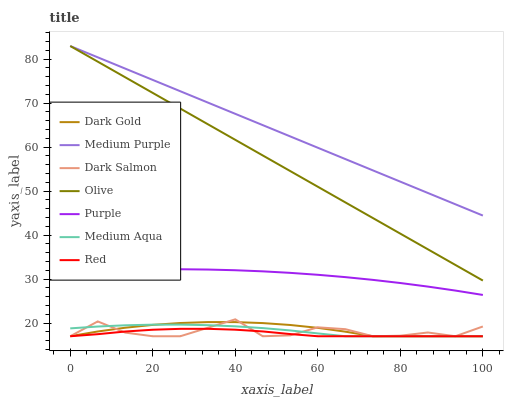Does Red have the minimum area under the curve?
Answer yes or no. Yes. Does Medium Purple have the maximum area under the curve?
Answer yes or no. Yes. Does Purple have the minimum area under the curve?
Answer yes or no. No. Does Purple have the maximum area under the curve?
Answer yes or no. No. Is Medium Purple the smoothest?
Answer yes or no. Yes. Is Dark Salmon the roughest?
Answer yes or no. Yes. Is Purple the smoothest?
Answer yes or no. No. Is Purple the roughest?
Answer yes or no. No. Does Dark Gold have the lowest value?
Answer yes or no. Yes. Does Purple have the lowest value?
Answer yes or no. No. Does Olive have the highest value?
Answer yes or no. Yes. Does Purple have the highest value?
Answer yes or no. No. Is Medium Aqua less than Purple?
Answer yes or no. Yes. Is Purple greater than Red?
Answer yes or no. Yes. Does Medium Purple intersect Olive?
Answer yes or no. Yes. Is Medium Purple less than Olive?
Answer yes or no. No. Is Medium Purple greater than Olive?
Answer yes or no. No. Does Medium Aqua intersect Purple?
Answer yes or no. No. 